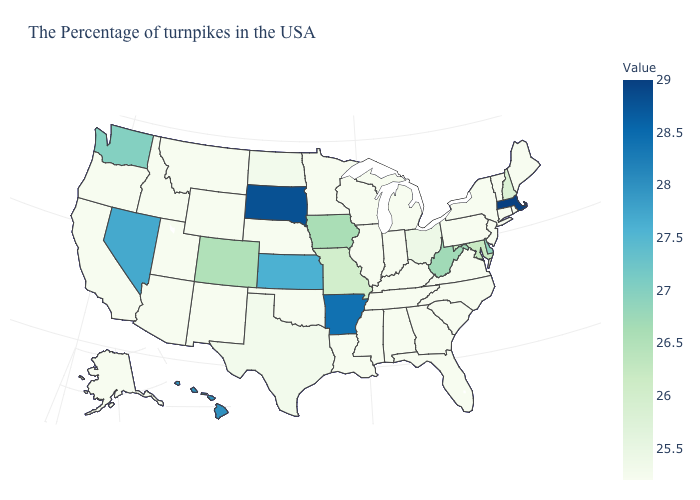Which states have the lowest value in the USA?
Quick response, please. Maine, Rhode Island, Vermont, Connecticut, New York, New Jersey, Pennsylvania, Virginia, North Carolina, South Carolina, Florida, Georgia, Michigan, Kentucky, Indiana, Alabama, Tennessee, Wisconsin, Illinois, Mississippi, Louisiana, Minnesota, Nebraska, Oklahoma, Wyoming, New Mexico, Utah, Montana, Arizona, Idaho, California, Oregon, Alaska. 